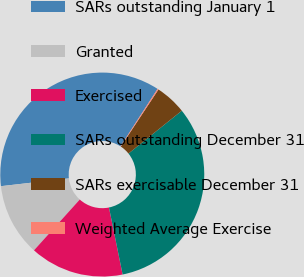Convert chart. <chart><loc_0><loc_0><loc_500><loc_500><pie_chart><fcel>SARs outstanding January 1<fcel>Granted<fcel>Exercised<fcel>SARs outstanding December 31<fcel>SARs exercisable December 31<fcel>Weighted Average Exercise<nl><fcel>35.93%<fcel>11.51%<fcel>14.87%<fcel>32.57%<fcel>4.94%<fcel>0.17%<nl></chart> 